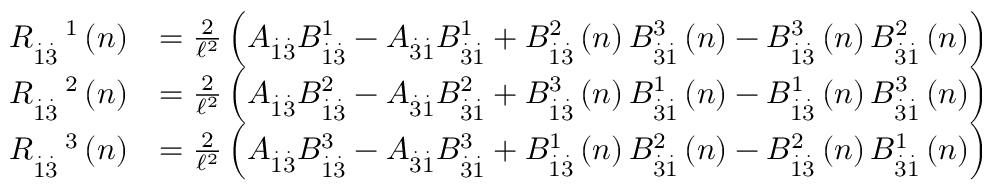<formula> <loc_0><loc_0><loc_500><loc_500>\begin{array} { r l } { R _ { \overset { . } { 1 } \overset { . } { 3 } } ^ { \quad 1 } \left ( n \right ) } & { = \frac { 2 } { \mathcal { \ell } ^ { 2 } } \left ( A _ { \overset { . } { 1 } \overset { . } { 3 } } B _ { \overset { . } { 1 } \overset { . } { 3 } } ^ { 1 } - A _ { \overset { . } { 3 } \overset { . } { 1 } } B _ { \overset { . } { 3 } \overset { . } { 1 } } ^ { 1 } + B _ { \overset { . } { 1 } \overset { . } { 3 } } ^ { 2 } \left ( n \right ) B _ { \overset { . } { 3 } \overset { . } { 1 } } ^ { 3 } \left ( n \right ) - B _ { \overset { . } { 1 } \overset { . } { 3 } } ^ { 3 } \left ( n \right ) B _ { \overset { . } { 3 } \overset { . } { 1 } } ^ { 2 } \left ( n \right ) \right ) } \\ { R _ { \overset { . } { 1 } \overset { . } { 3 } } ^ { \quad 2 } \left ( n \right ) } & { = \frac { 2 } { \mathcal { \ell } ^ { 2 } } \left ( A _ { \overset { . } { 1 } \overset { . } { 3 } } B _ { \overset { . } { 1 } \overset { . } { 3 } } ^ { 2 } - A _ { \overset { . } { 3 } \overset { . } { 1 } } B _ { \overset { . } { 3 } \overset { . } { 1 } } ^ { 2 } + B _ { \overset { . } { 1 } \overset { . } { 3 } } ^ { 3 } \left ( n \right ) B _ { \overset { . } { 3 } \overset { . } { 1 } } ^ { 1 } \left ( n \right ) - B _ { \overset { . } { 1 } \overset { . } { 3 } } ^ { 1 } \left ( n \right ) B _ { \overset { . } { 3 } \overset { . } { 1 } } ^ { 3 } \left ( n \right ) \right ) } \\ { R _ { \overset { . } { 1 } \overset { . } { 3 } } ^ { \quad 3 } \left ( n \right ) } & { = \frac { 2 } { \mathcal { \ell } ^ { 2 } } \left ( A _ { \overset { . } { 1 } \overset { . } { 3 } } B _ { \overset { . } { 1 } \overset { . } { 3 } } ^ { 3 } - A _ { \overset { . } { 3 } \overset { . } { 1 } } B _ { \overset { . } { 3 } \overset { . } { 1 } } ^ { 3 } + B _ { \overset { . } { 1 } \overset { . } { 3 } } ^ { 1 } \left ( n \right ) B _ { \overset { . } { 3 } \overset { . } { 1 } } ^ { 2 } \left ( n \right ) - B _ { \overset { . } { 1 } \overset { . } { 3 } } ^ { 2 } \left ( n \right ) B _ { \overset { . } { 3 } \overset { . } { 1 } } ^ { 1 } \left ( n \right ) \right ) } \end{array}</formula> 